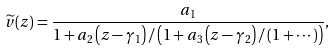<formula> <loc_0><loc_0><loc_500><loc_500>\widetilde { v } ( z ) = \frac { a _ { 1 } } { 1 + a _ { 2 } \left ( z - \gamma _ { 1 } \right ) / \left ( 1 + a _ { 3 } \left ( z - \gamma _ { 2 } \right ) / \left ( 1 + \cdots \right ) \right ) } ,</formula> 